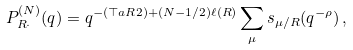Convert formula to latex. <formula><loc_0><loc_0><loc_500><loc_500>P _ { R \cdot } ^ { ( N ) } ( q ) = q ^ { - \left ( \top a { R } { 2 } \right ) + ( N - 1 / 2 ) \ell ( R ) } \sum _ { \mu } s _ { \mu / R } ( q ^ { - \rho } ) \, ,</formula> 